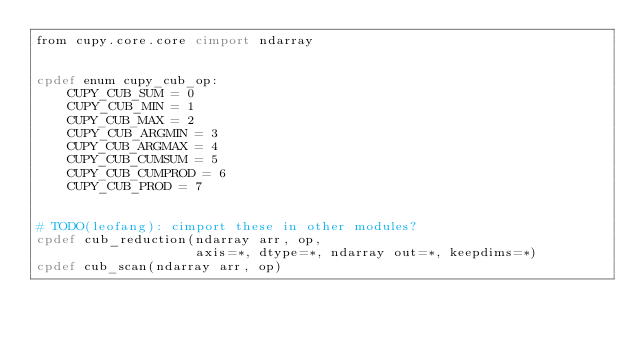Convert code to text. <code><loc_0><loc_0><loc_500><loc_500><_Cython_>from cupy.core.core cimport ndarray


cpdef enum cupy_cub_op:
    CUPY_CUB_SUM = 0
    CUPY_CUB_MIN = 1
    CUPY_CUB_MAX = 2
    CUPY_CUB_ARGMIN = 3
    CUPY_CUB_ARGMAX = 4
    CUPY_CUB_CUMSUM = 5
    CUPY_CUB_CUMPROD = 6
    CUPY_CUB_PROD = 7


# TODO(leofang): cimport these in other modules?
cpdef cub_reduction(ndarray arr, op,
                    axis=*, dtype=*, ndarray out=*, keepdims=*)
cpdef cub_scan(ndarray arr, op)
</code> 